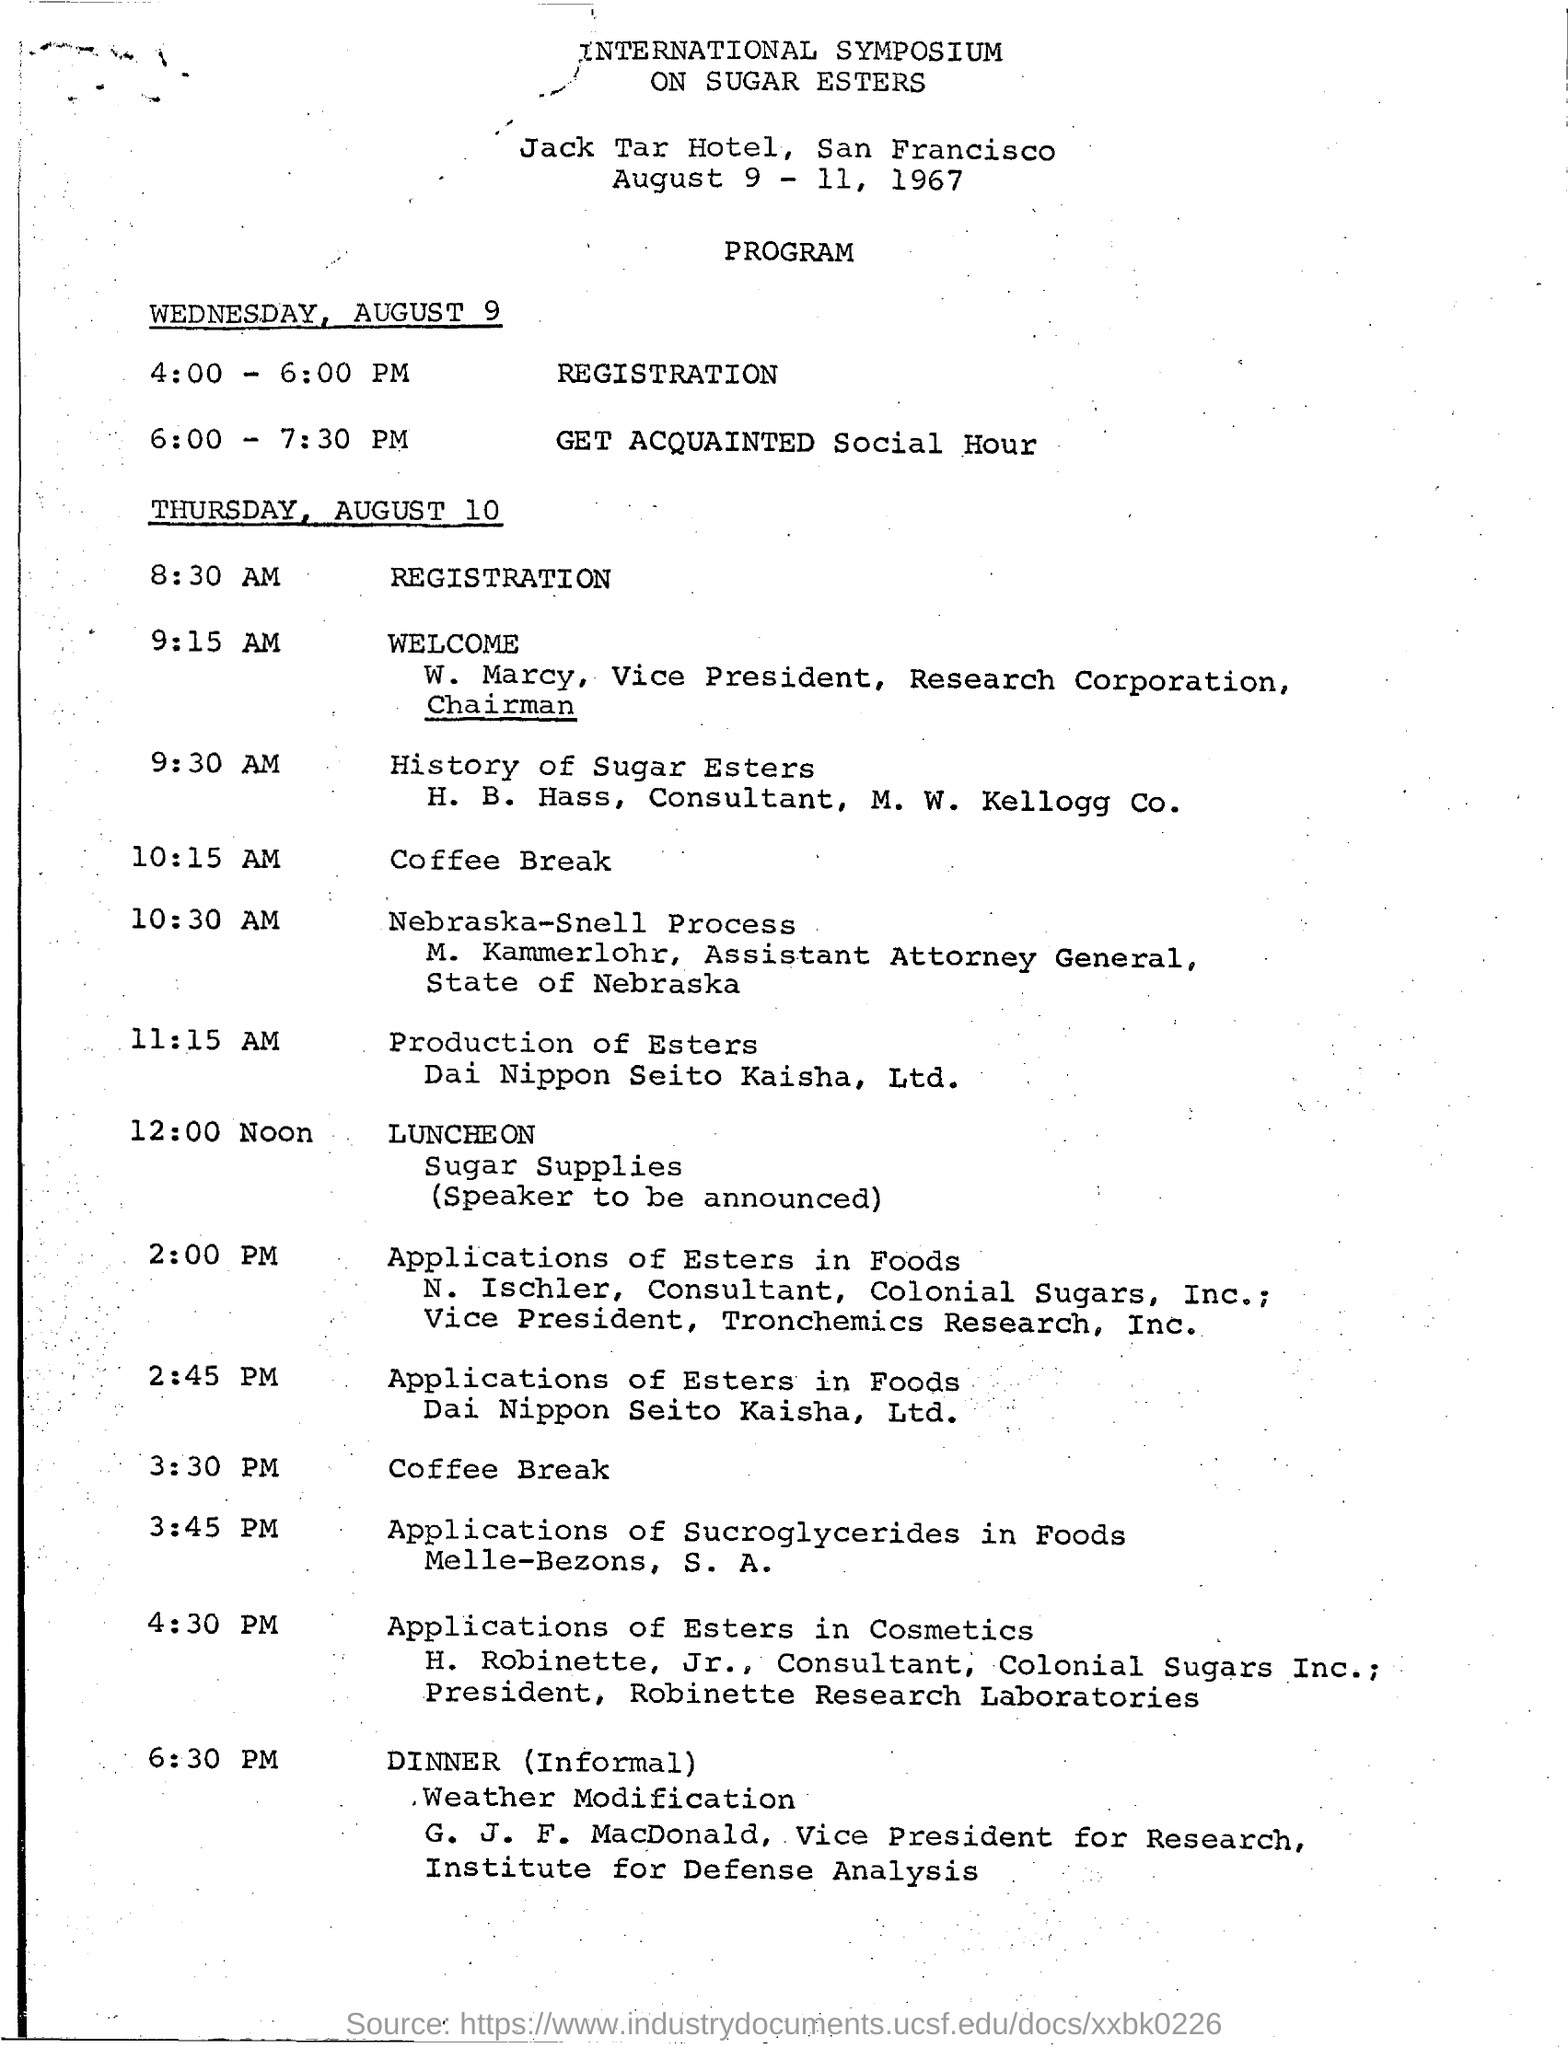Point out several critical features in this image. The program scheduled between 6:00 PM and 7:30 PM is the Get Acquainted Social Hour. The program scheduled for 8:30 am on Thursday, August 10 is titled 'Registration.' What is the program that is scheduled to occur at 9:15 am on Thursday, August 10th? At 12:00 noon, the program was "Luncheon. The program scheduled for 4:00-6:00 pm on Wednesday, August 9, is registration. 